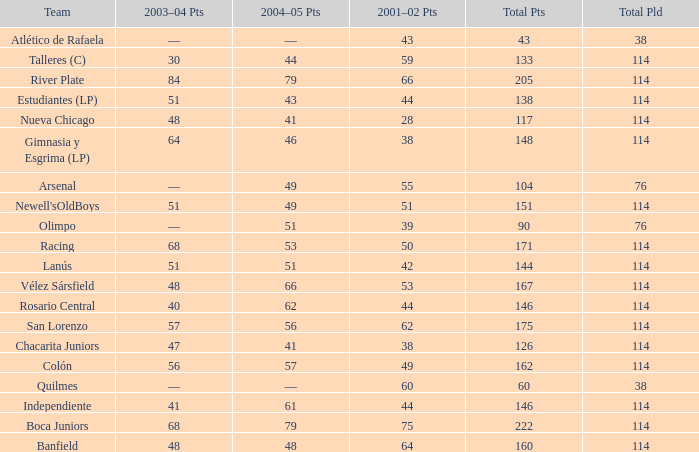Which Total Pts have a 2001–02 Pts smaller than 38? 117.0. 